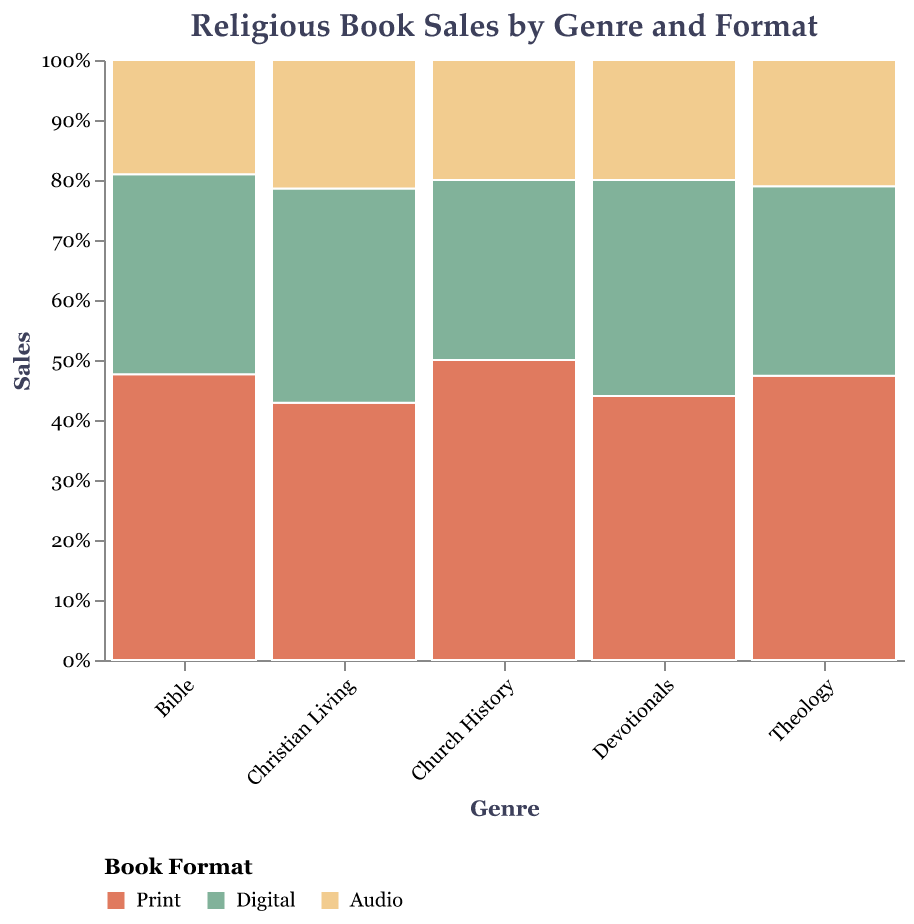What's the title of the figure? The title is located at the top of the figure and typically provides a concise description of the data being visualized. In this figure, the title is "Religious Book Sales by Genre and Format".
Answer: Religious Book Sales by Genre and Format Which book format had the highest sales in the Bible genre? To determine the highest sales format within the Bible genre, examine the different colored sections within the "Bible" category on the x-axis. The "Print" format, represented by a specific color, takes up the largest proportion of the stack.
Answer: Print What is the total number of sales for the Christian Living genre across all formats? Sum the sales numbers for each format in the Christian Living genre: Print: 3000, Digital: 2500, Audio: 1500. Total sales = 3000 + 2500 + 1500.
Answer: 7000 Compare the audio book sales in the Theology and Devotionals genres. Which one is higher? Look at the proportions of the Audio format (indicated by the respective color) within the Theology and Devotionals genres. Theology has 800 sales and Devotionals has 1000 sales in the Audio format, making Devotionals higher.
Answer: Devotionals What proportion of Devotionals sales comes from Digital format? The Digital format for Devotionals has 1800 sales out of the total 5000 (Print: 2200, Digital: 1800, Audio: 1000). Calculate the proportion: 1800/5000 = 0.36. So, the proportion is 36%.
Answer: 36% Which genre has the lowest sales in the Print format? By examining the height of the bars in the Print format (color-coded) across the genres, Church History has the smallest bar, indicating the lowest sales.
Answer: Church History Are Audio sales generally higher in the Bible genre compared to the Church History genre? Compare the Audio format sales proportions between the Bible (2000 sales) and Church History (600 sales) genres. Since 2000 is greater than 600, the Audio sales for the Bible genre are generally higher.
Answer: Yes Identify the genre with the second highest proportion of Digital format sales. First, look at the Digital format proportions within each genre. After identifying the highest (Bible), determine the second highest by comparing the remaining genres. Christian Living has Digital sales close to Bible.
Answer: Christian Living What is the difference in Print sales between Bible and Theology genres? Subtract the Print sales of the Theology genre from the Bible genre: 5000 (Bible) - 1800 (Theology) = 3200.
Answer: 3200 